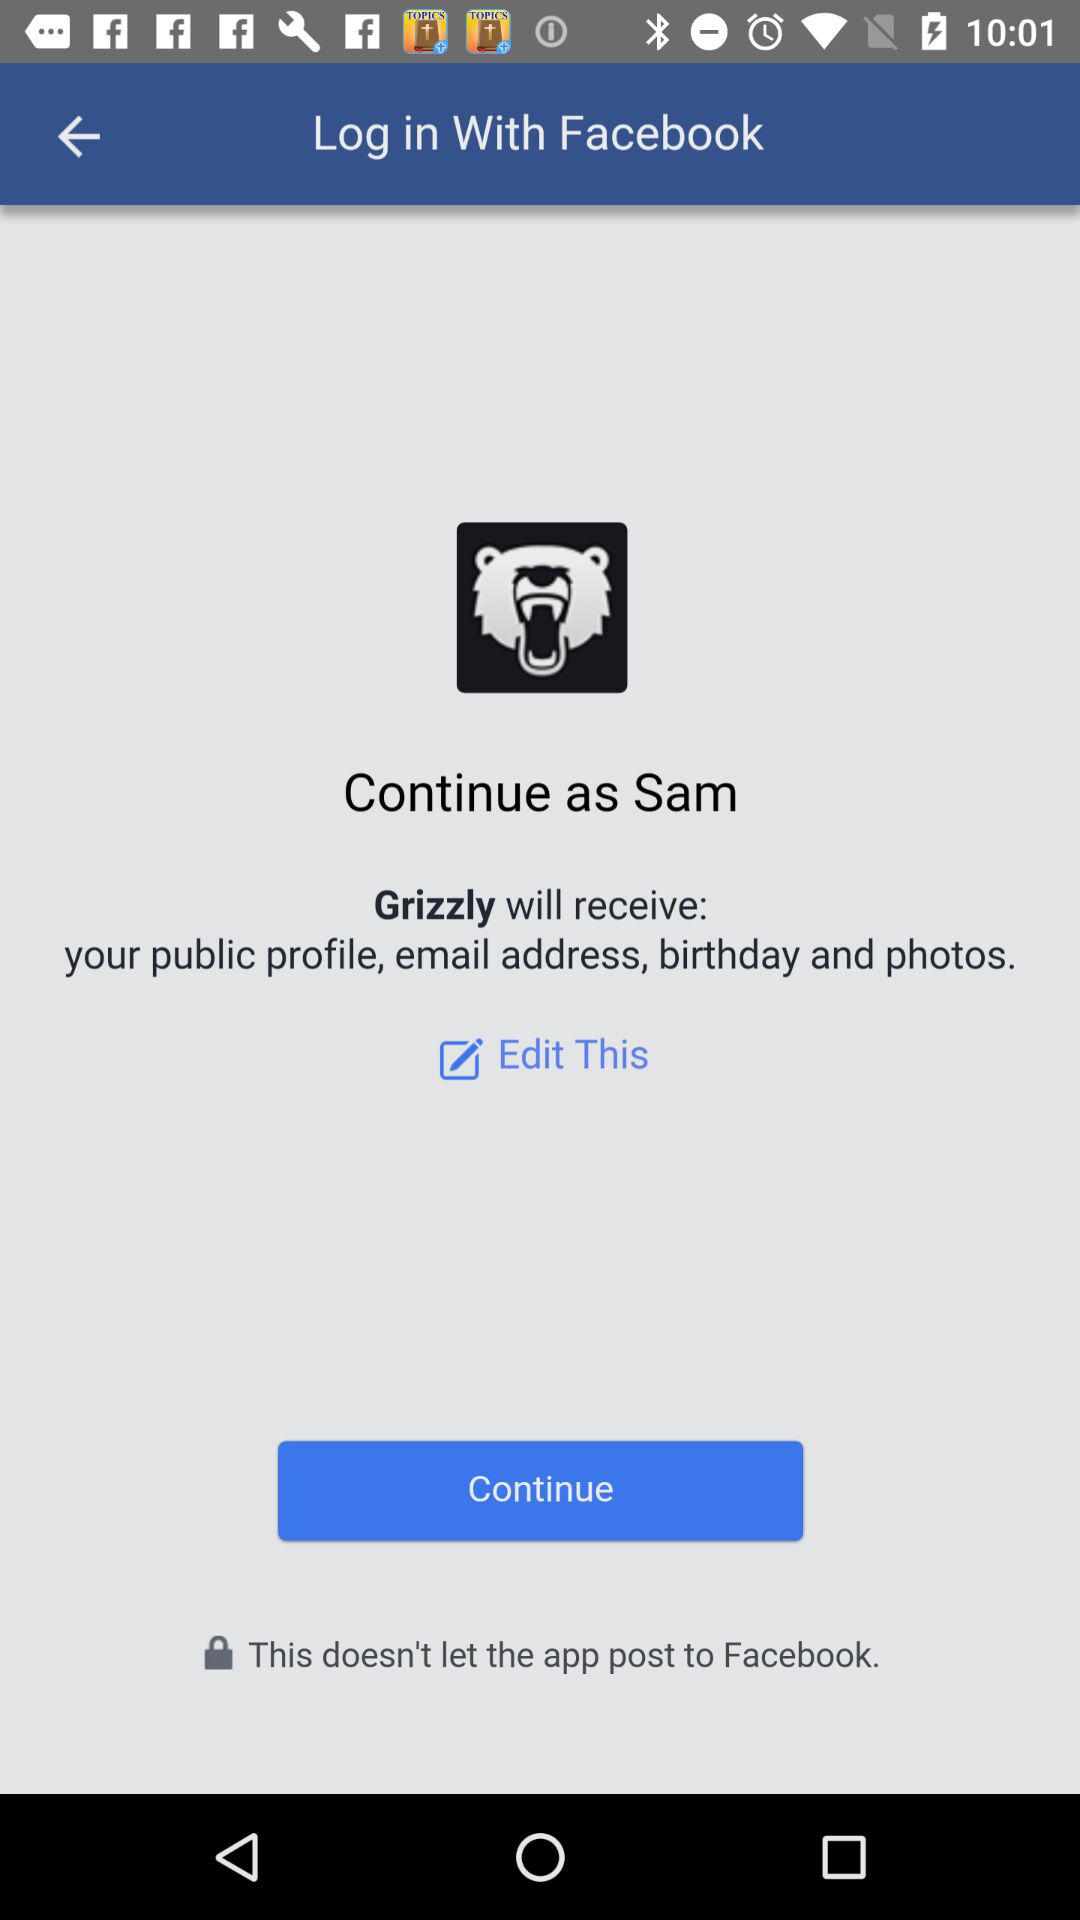What is the user name? The user name is Sam. 